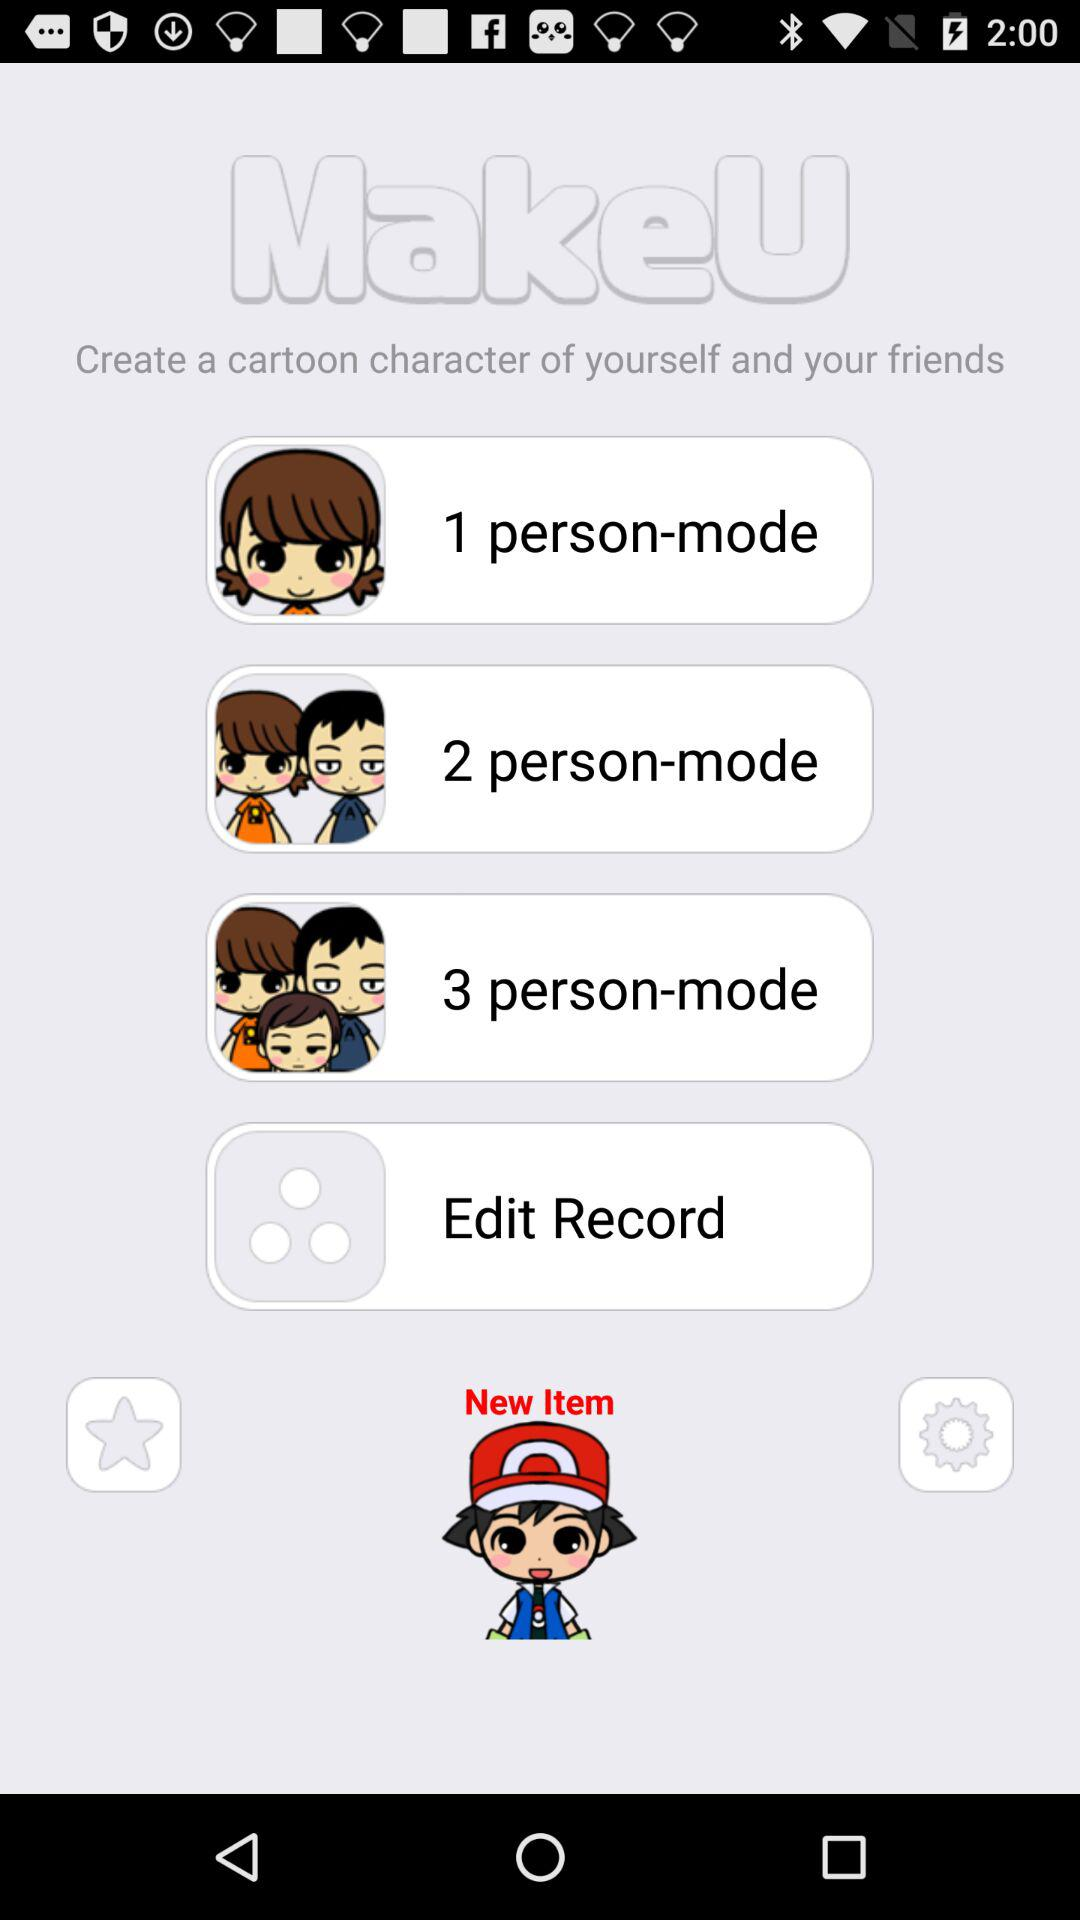What is the application name? The application name is "MakeU". 